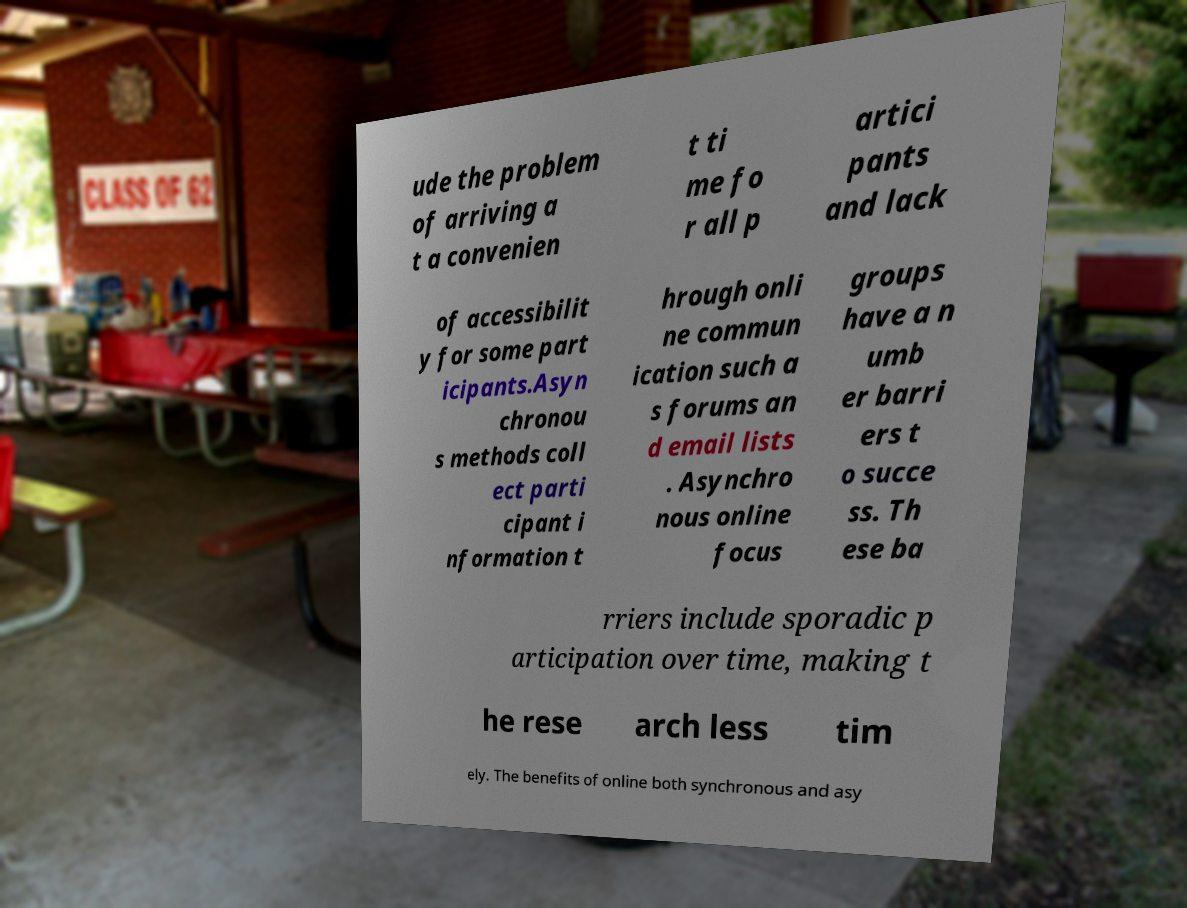There's text embedded in this image that I need extracted. Can you transcribe it verbatim? ude the problem of arriving a t a convenien t ti me fo r all p artici pants and lack of accessibilit y for some part icipants.Asyn chronou s methods coll ect parti cipant i nformation t hrough onli ne commun ication such a s forums an d email lists . Asynchro nous online focus groups have a n umb er barri ers t o succe ss. Th ese ba rriers include sporadic p articipation over time, making t he rese arch less tim ely. The benefits of online both synchronous and asy 